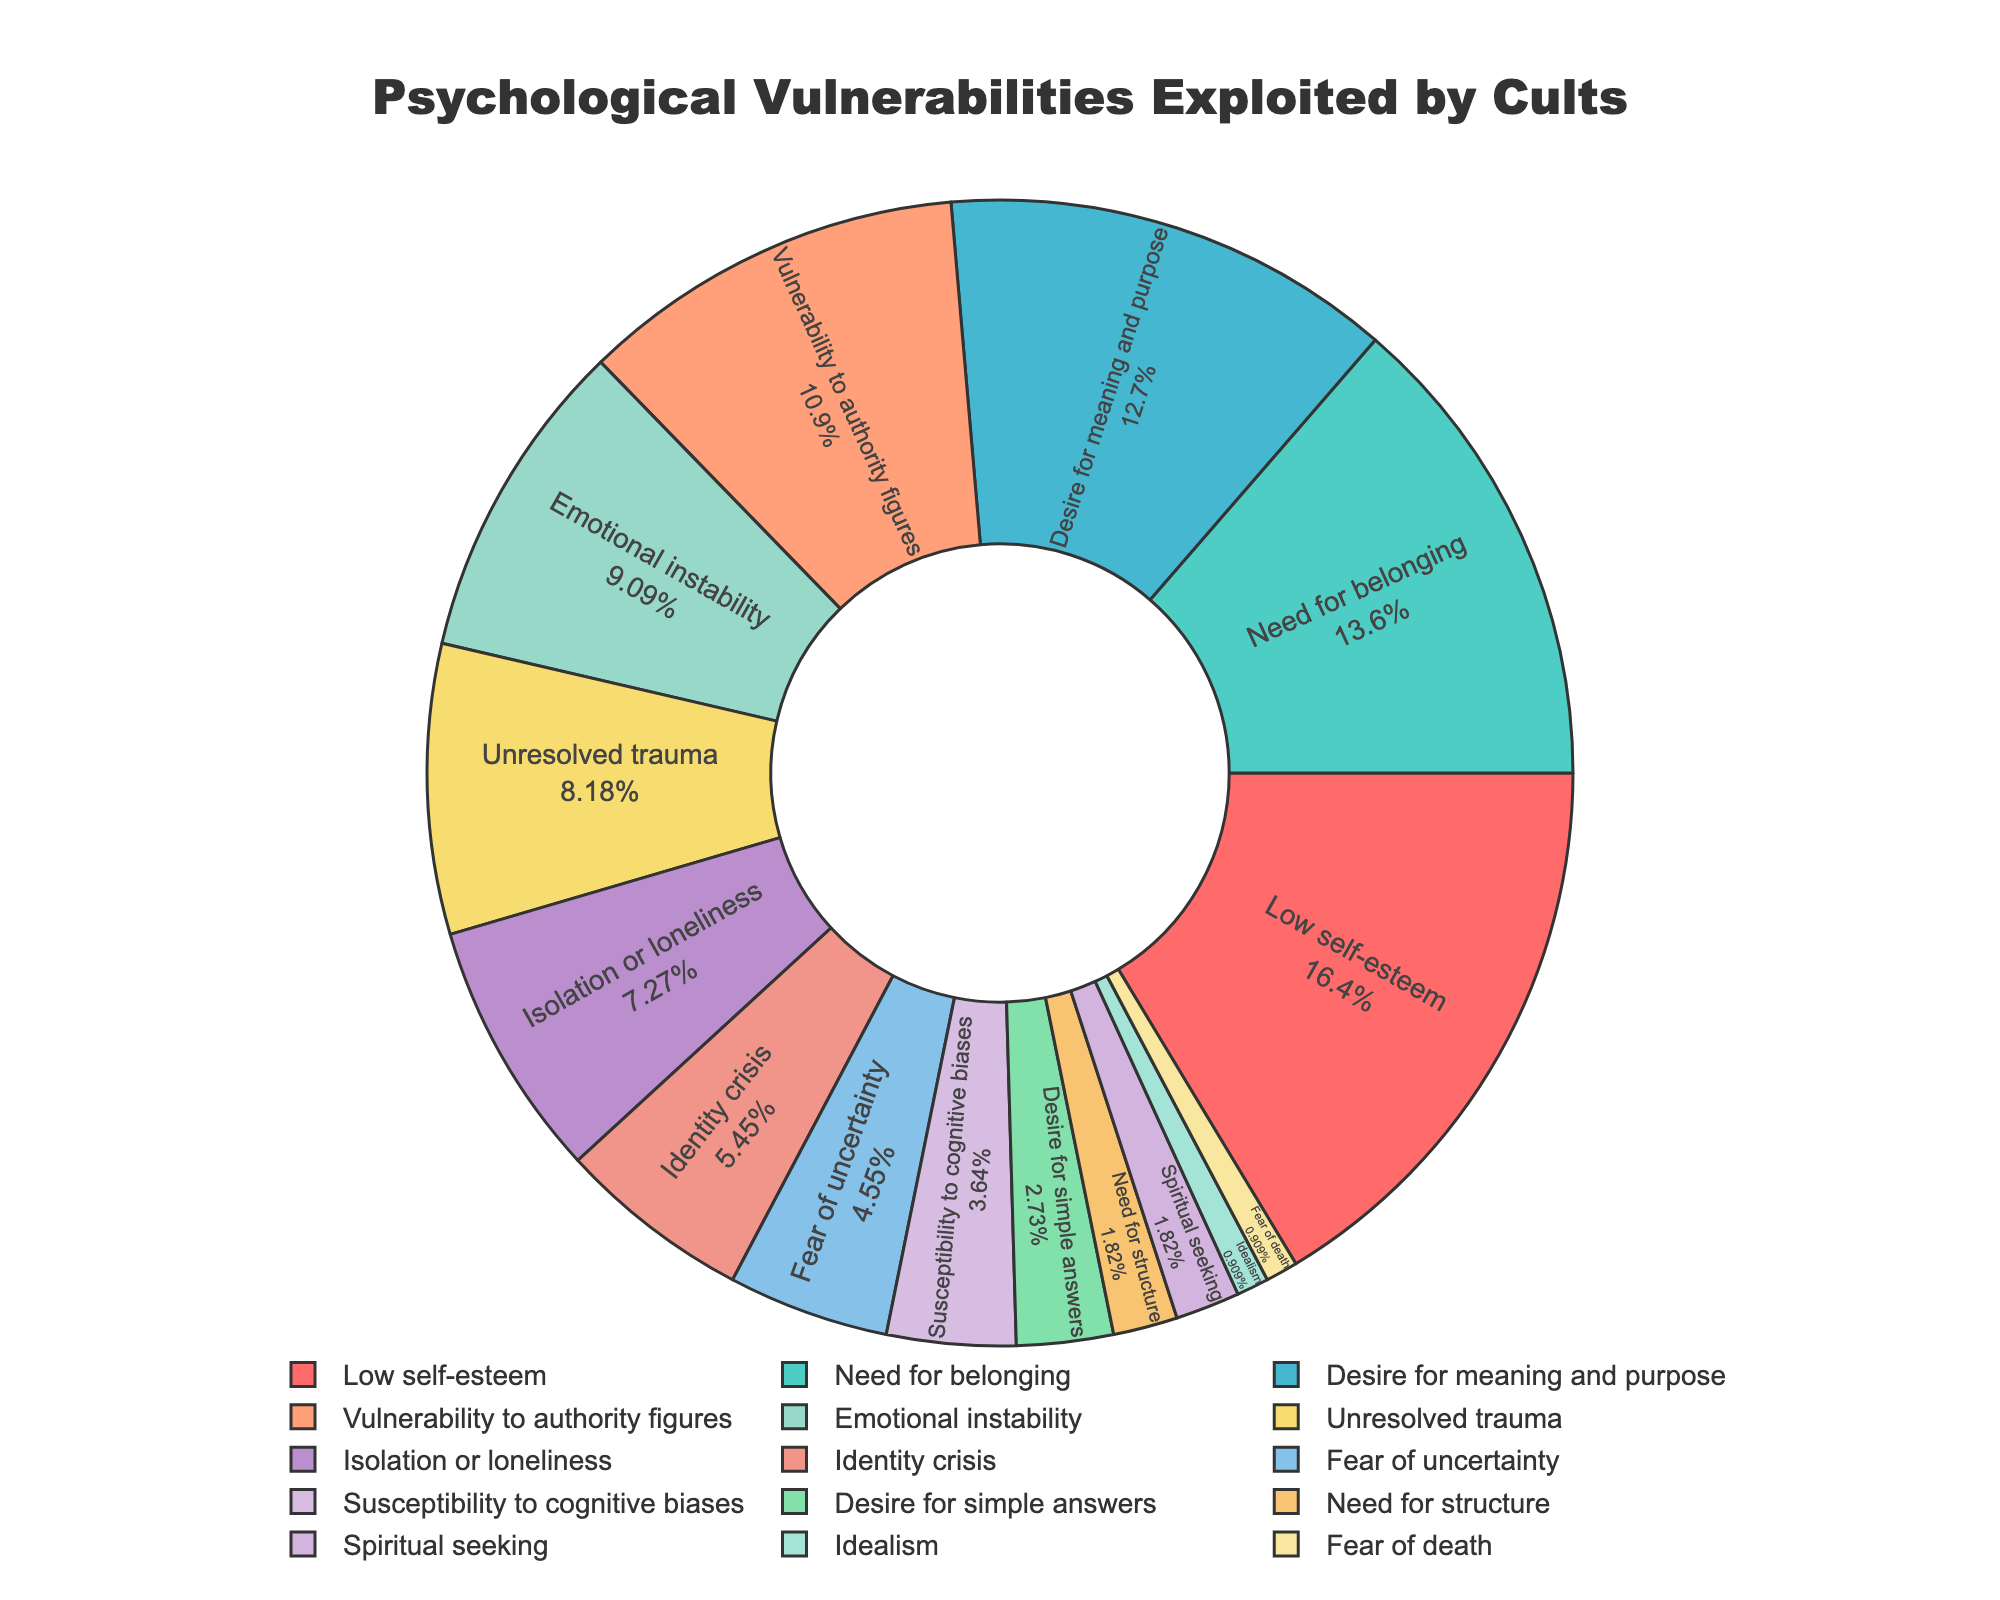Which category has the highest percentage of psychological vulnerabilities exploited by cults? The largest segment in the pie chart is labeled "Low self-esteem" with 18%
Answer: Low self-esteem What is the combined percentage of categories related to social needs (Need for belonging and Isolation or loneliness)? The "Need for belonging" is 15% and "Isolation or loneliness" is 8%. Adding these two percentages gives 15% + 8% = 23%
Answer: 23% Which three categories have the smallest percentages? Observing the smallest segments on the pie chart, the three smallest categories are "Fear of death" with 1%, "Idealism" with 1%, and "Spiritual seeking" with 2%
Answer: Fear of death, Idealism, Spiritual seeking What is the percentage difference between "Low self-esteem" and "Vulnerability to authority figures"? "Low self-esteem" is 18% and "Vulnerability to authority figures" is 12%. The difference is 18% - 12% = 6%
Answer: 6% Which category is represented by a green color in the pie chart? The color green is used for "Need for belonging" which has 15%
Answer: Need for belonging What are the total percentages of psychological vulnerabilities related to emotional aspects (Low self-esteem, Emotional instability, Unresolved trauma)? "Low self-esteem" is 18%, "Emotional instability" is 10%, and "Unresolved trauma" is 9%. Summing them up gives 18% + 10% + 9% = 37%
Answer: 37% Which two categories have a cumulative percentage of 16%? "Identity crisis" at 6% and "Fear of uncertainty" at 5% add up to 11%, but "Spiritual seeking" at 2% combined with "Need for structure" at 2% gives only 4%. "Susceptibility to cognitive biases" at 4% paired with "Desire for simple answers" at 3% gives only 7%. "Idealism" at 1% and "Fear of death" at 1% give only 2%. Therefore, "Unresolved trauma" at 9% combined with "Isolation or loneliness" at 8% gives 17%, exceeding the required value. Consequently, two smallest shares have sum of 1% + 1% + 2% + 2% + 3% gives exact 9% however it is not two values
Answer: None 